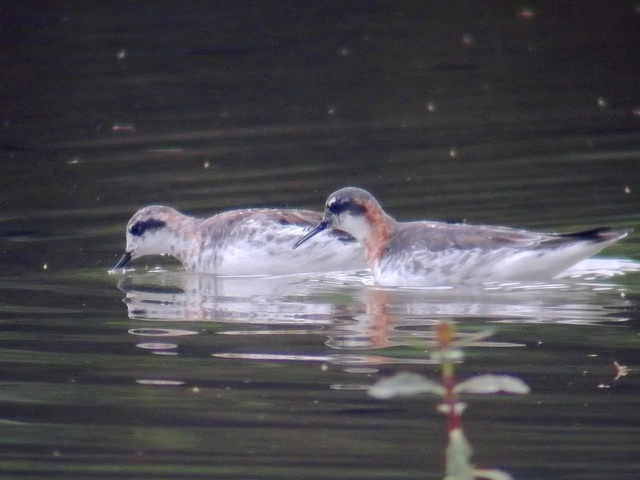Describe the objects in this image and their specific colors. I can see bird in black, darkgray, lavender, and gray tones and bird in black, darkgray, lavender, and lightgray tones in this image. 